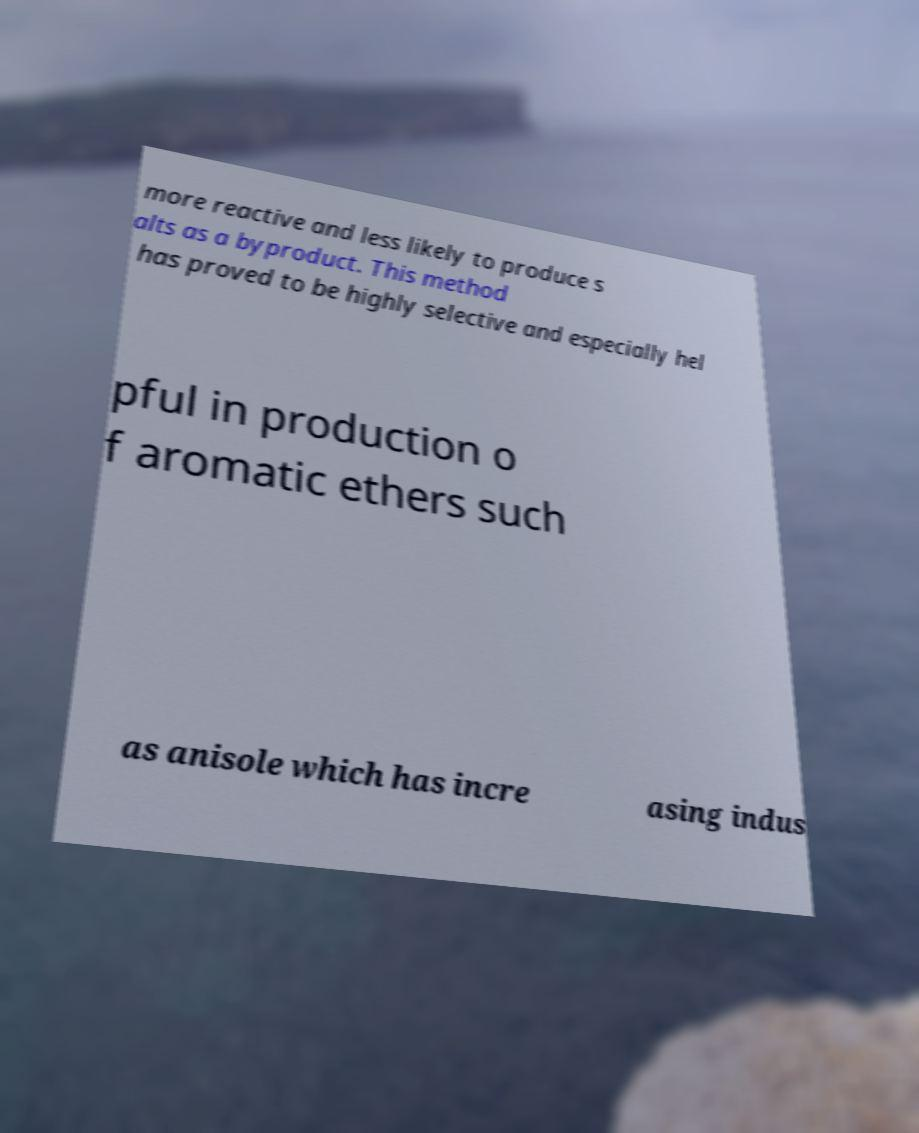Can you accurately transcribe the text from the provided image for me? more reactive and less likely to produce s alts as a byproduct. This method has proved to be highly selective and especially hel pful in production o f aromatic ethers such as anisole which has incre asing indus 